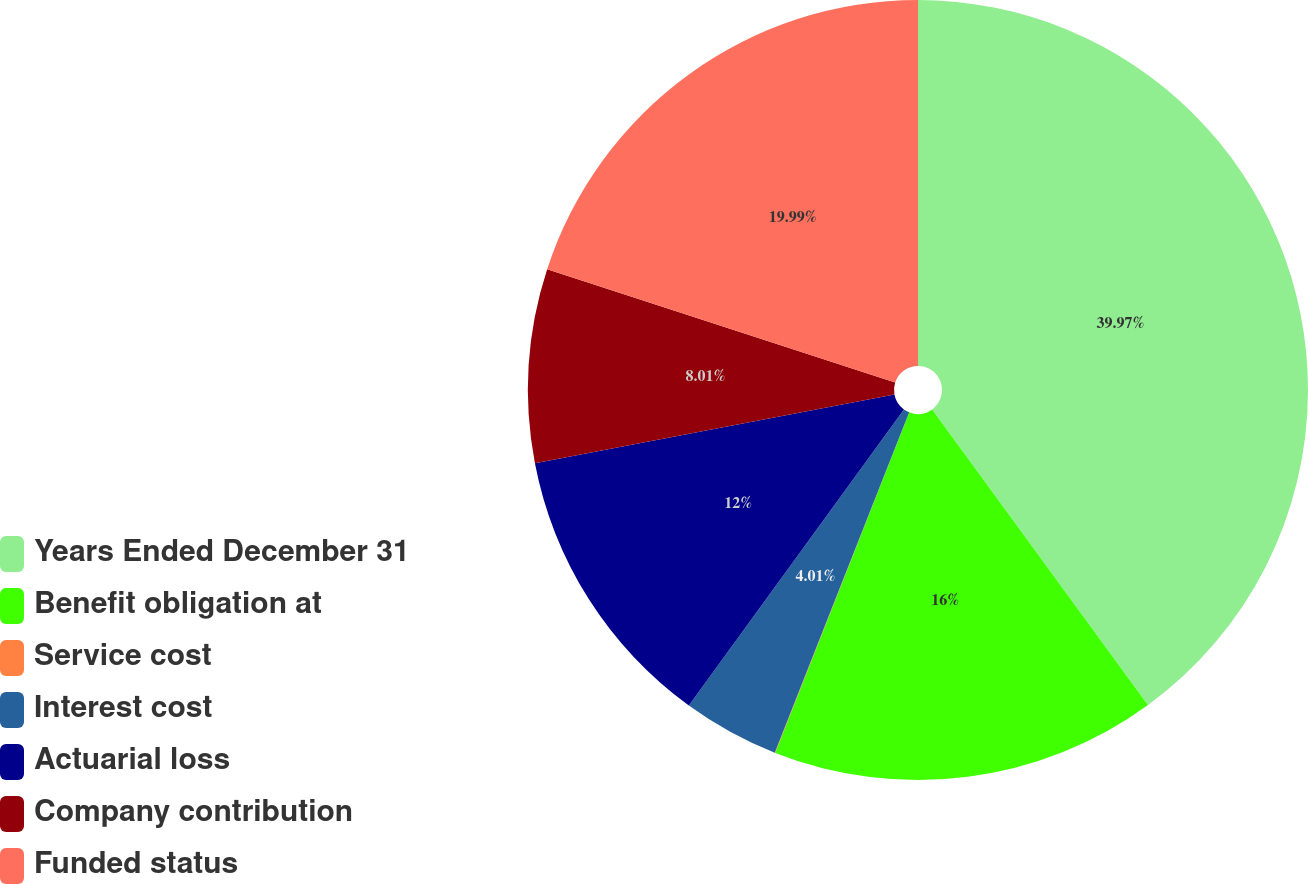<chart> <loc_0><loc_0><loc_500><loc_500><pie_chart><fcel>Years Ended December 31<fcel>Benefit obligation at<fcel>Service cost<fcel>Interest cost<fcel>Actuarial loss<fcel>Company contribution<fcel>Funded status<nl><fcel>39.96%<fcel>16.0%<fcel>0.02%<fcel>4.01%<fcel>12.0%<fcel>8.01%<fcel>19.99%<nl></chart> 